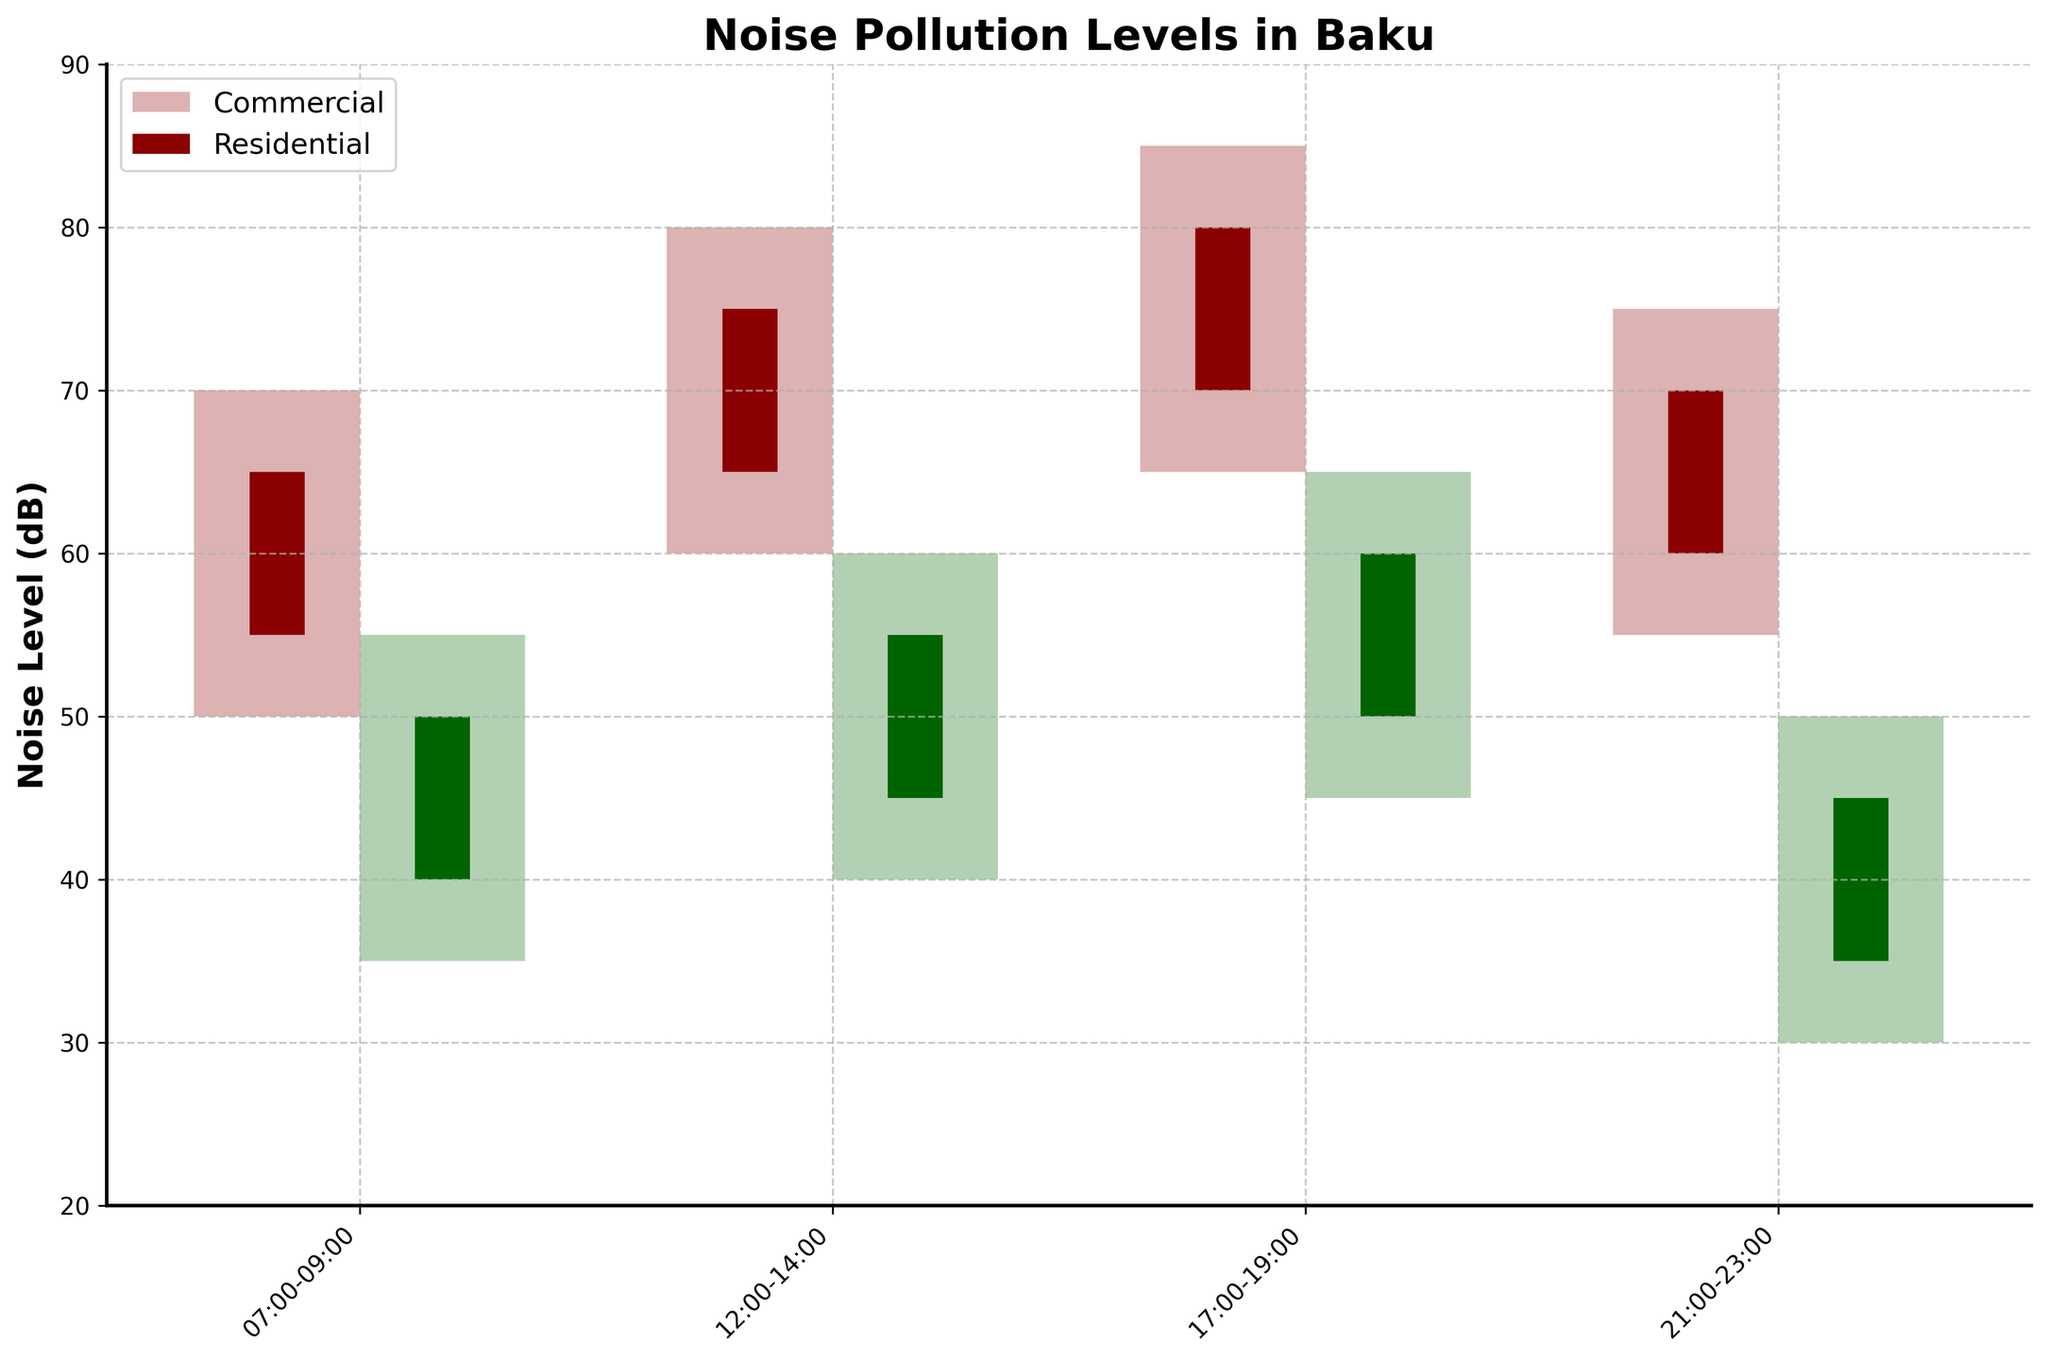What is the title of the figure? The title of the figure can be seen at the top, and it reads "Noise Pollution Levels in Baku." This can be identified as it is in a larger and bold font compared to other texts in the figure.
Answer: Noise Pollution Levels in Baku What time period has the highest noise level in commercial areas? To find the highest noise level in commercial areas, look at the highest points (High value) among all the time periods for commercial areas. The highest point is 85 dB in the period 17:00-19:00.
Answer: 17:00-19:00 Compare the lowest noise levels in residential areas at different times of the day. To compare the lowest noise levels, examine the Low values for residential areas. They are 35, 40, 45, and 30 dB for 07:00-09:00, 12:00-14:00, 17:00-19:00, and 21:00-23:00, respectively. The lowest value is 30 dB during 21:00-23:00.
Answer: 30 dB during 21:00-23:00 What is the median value of the noise levels in the commercial area from 17:00-19:00? For candlestick plots, the Open, High, Low, and Close values can be considered. For 17:00-19:00 in commercial area, they are 70, 85, 65, and 80. The median is the average of the second and third values when arranged in order: (70, 80, 65, 85) → (65, 70, 80, 85), median = (70 + 80)/2 = 75.
Answer: 75 dB How do the noise levels compare between commercial and residential areas in the morning (07:00-09:00)? For the 07:00-09:00 period, look at the data for commercial (Open: 55, High: 70, Low: 50, Close: 65) and residential (Open: 40, High: 55, Low: 35, Close: 50) areas. All the values in commercial areas are higher than those for residential areas, indicating higher noise levels in commercial areas during the morning.
Answer: Higher in commercial areas Which area shows more variation in noise levels during 12:00-14:00? Variation can be evaluated by the range (High - Low) for each area. For 12:00-14:00, the range for commercial is 80 - 60 = 20 dB, and for residential, it is 60 - 40 = 20 dB. Both areas show the same variation.
Answer: Same variation in both areas What can be inferred about residential noise levels from 21:00-23:00 compared to earlier periods? The residential noise levels (Low values) decrease to 30 dB from higher values (35, 40, 45 dB in earlier periods). This suggests that residential noise levels drop significantly during 21:00-23:00 compared to earlier times of the day.
Answer: Noise levels drop significantly Between 17:00-19:00, which area is quieter on average? The average of Open, High, Low, and Close values for 17:00-19:00: Commercial average = (70 + 85 + 65 + 80)/4 = 75, Residential average = (50 + 65 + 45 + 60)/4 = 55. The residential area is quieter on average.
Answer: Residential area During which time period is the residential area noise level highest? The highest residential noise levels can be seen by looking at the High values. The highest value is 65 dB during 17:00-19:00.
Answer: 17:00-19:00 